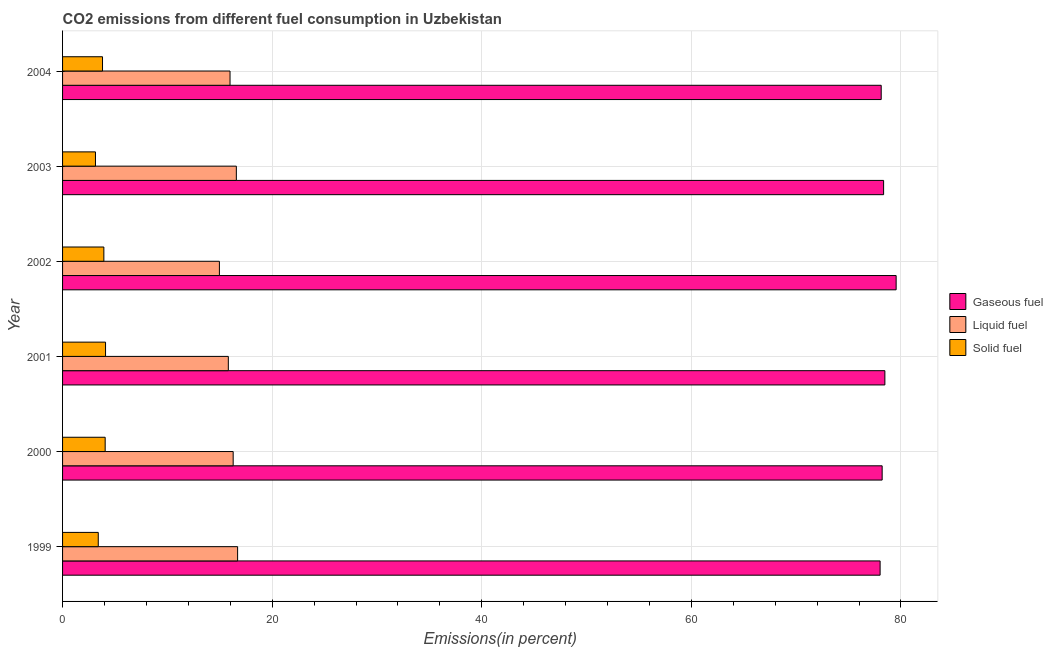How many different coloured bars are there?
Provide a short and direct response. 3. How many groups of bars are there?
Provide a succinct answer. 6. Are the number of bars per tick equal to the number of legend labels?
Keep it short and to the point. Yes. Are the number of bars on each tick of the Y-axis equal?
Offer a terse response. Yes. What is the label of the 2nd group of bars from the top?
Make the answer very short. 2003. What is the percentage of liquid fuel emission in 2004?
Your answer should be very brief. 15.98. Across all years, what is the maximum percentage of liquid fuel emission?
Keep it short and to the point. 16.7. Across all years, what is the minimum percentage of gaseous fuel emission?
Keep it short and to the point. 78.01. In which year was the percentage of gaseous fuel emission maximum?
Give a very brief answer. 2002. What is the total percentage of solid fuel emission in the graph?
Your answer should be very brief. 22.46. What is the difference between the percentage of gaseous fuel emission in 1999 and that in 2000?
Give a very brief answer. -0.2. What is the difference between the percentage of gaseous fuel emission in 2001 and the percentage of solid fuel emission in 1999?
Offer a terse response. 75.06. What is the average percentage of gaseous fuel emission per year?
Your response must be concise. 78.44. In the year 2001, what is the difference between the percentage of gaseous fuel emission and percentage of liquid fuel emission?
Provide a short and direct response. 62.65. Is the percentage of solid fuel emission in 1999 less than that in 2001?
Offer a very short reply. Yes. What is the difference between the highest and the second highest percentage of gaseous fuel emission?
Keep it short and to the point. 1.07. What is the difference between the highest and the lowest percentage of liquid fuel emission?
Keep it short and to the point. 1.74. In how many years, is the percentage of gaseous fuel emission greater than the average percentage of gaseous fuel emission taken over all years?
Give a very brief answer. 2. What does the 1st bar from the top in 1999 represents?
Your answer should be very brief. Solid fuel. What does the 1st bar from the bottom in 2002 represents?
Offer a very short reply. Gaseous fuel. How many bars are there?
Provide a short and direct response. 18. Are all the bars in the graph horizontal?
Provide a succinct answer. Yes. What is the difference between two consecutive major ticks on the X-axis?
Provide a short and direct response. 20. Does the graph contain grids?
Provide a succinct answer. Yes. Where does the legend appear in the graph?
Keep it short and to the point. Center right. How are the legend labels stacked?
Provide a succinct answer. Vertical. What is the title of the graph?
Your answer should be compact. CO2 emissions from different fuel consumption in Uzbekistan. What is the label or title of the X-axis?
Your answer should be very brief. Emissions(in percent). What is the label or title of the Y-axis?
Provide a succinct answer. Year. What is the Emissions(in percent) of Gaseous fuel in 1999?
Your answer should be very brief. 78.01. What is the Emissions(in percent) in Liquid fuel in 1999?
Ensure brevity in your answer.  16.7. What is the Emissions(in percent) in Solid fuel in 1999?
Your answer should be compact. 3.41. What is the Emissions(in percent) of Gaseous fuel in 2000?
Give a very brief answer. 78.2. What is the Emissions(in percent) in Liquid fuel in 2000?
Keep it short and to the point. 16.28. What is the Emissions(in percent) in Solid fuel in 2000?
Provide a short and direct response. 4.07. What is the Emissions(in percent) of Gaseous fuel in 2001?
Provide a short and direct response. 78.46. What is the Emissions(in percent) of Liquid fuel in 2001?
Make the answer very short. 15.82. What is the Emissions(in percent) of Solid fuel in 2001?
Make the answer very short. 4.1. What is the Emissions(in percent) in Gaseous fuel in 2002?
Keep it short and to the point. 79.54. What is the Emissions(in percent) of Liquid fuel in 2002?
Offer a very short reply. 14.97. What is the Emissions(in percent) in Solid fuel in 2002?
Your response must be concise. 3.94. What is the Emissions(in percent) of Gaseous fuel in 2003?
Provide a short and direct response. 78.34. What is the Emissions(in percent) in Liquid fuel in 2003?
Offer a very short reply. 16.58. What is the Emissions(in percent) of Solid fuel in 2003?
Give a very brief answer. 3.14. What is the Emissions(in percent) of Gaseous fuel in 2004?
Your response must be concise. 78.11. What is the Emissions(in percent) of Liquid fuel in 2004?
Give a very brief answer. 15.98. What is the Emissions(in percent) of Solid fuel in 2004?
Provide a succinct answer. 3.81. Across all years, what is the maximum Emissions(in percent) in Gaseous fuel?
Your answer should be compact. 79.54. Across all years, what is the maximum Emissions(in percent) of Liquid fuel?
Your answer should be very brief. 16.7. Across all years, what is the maximum Emissions(in percent) of Solid fuel?
Your answer should be compact. 4.1. Across all years, what is the minimum Emissions(in percent) of Gaseous fuel?
Your response must be concise. 78.01. Across all years, what is the minimum Emissions(in percent) of Liquid fuel?
Keep it short and to the point. 14.97. Across all years, what is the minimum Emissions(in percent) in Solid fuel?
Your response must be concise. 3.14. What is the total Emissions(in percent) in Gaseous fuel in the graph?
Offer a terse response. 470.66. What is the total Emissions(in percent) of Liquid fuel in the graph?
Your answer should be compact. 96.32. What is the total Emissions(in percent) of Solid fuel in the graph?
Your response must be concise. 22.46. What is the difference between the Emissions(in percent) of Gaseous fuel in 1999 and that in 2000?
Make the answer very short. -0.19. What is the difference between the Emissions(in percent) of Liquid fuel in 1999 and that in 2000?
Your answer should be very brief. 0.42. What is the difference between the Emissions(in percent) of Solid fuel in 1999 and that in 2000?
Make the answer very short. -0.66. What is the difference between the Emissions(in percent) of Gaseous fuel in 1999 and that in 2001?
Give a very brief answer. -0.45. What is the difference between the Emissions(in percent) of Liquid fuel in 1999 and that in 2001?
Ensure brevity in your answer.  0.88. What is the difference between the Emissions(in percent) in Solid fuel in 1999 and that in 2001?
Keep it short and to the point. -0.7. What is the difference between the Emissions(in percent) of Gaseous fuel in 1999 and that in 2002?
Offer a terse response. -1.53. What is the difference between the Emissions(in percent) of Liquid fuel in 1999 and that in 2002?
Provide a succinct answer. 1.74. What is the difference between the Emissions(in percent) of Solid fuel in 1999 and that in 2002?
Offer a terse response. -0.53. What is the difference between the Emissions(in percent) in Gaseous fuel in 1999 and that in 2003?
Make the answer very short. -0.33. What is the difference between the Emissions(in percent) of Liquid fuel in 1999 and that in 2003?
Offer a terse response. 0.12. What is the difference between the Emissions(in percent) of Solid fuel in 1999 and that in 2003?
Ensure brevity in your answer.  0.27. What is the difference between the Emissions(in percent) in Gaseous fuel in 1999 and that in 2004?
Keep it short and to the point. -0.1. What is the difference between the Emissions(in percent) in Liquid fuel in 1999 and that in 2004?
Give a very brief answer. 0.72. What is the difference between the Emissions(in percent) of Solid fuel in 1999 and that in 2004?
Your response must be concise. -0.41. What is the difference between the Emissions(in percent) in Gaseous fuel in 2000 and that in 2001?
Offer a very short reply. -0.26. What is the difference between the Emissions(in percent) in Liquid fuel in 2000 and that in 2001?
Provide a succinct answer. 0.46. What is the difference between the Emissions(in percent) in Solid fuel in 2000 and that in 2001?
Keep it short and to the point. -0.04. What is the difference between the Emissions(in percent) in Gaseous fuel in 2000 and that in 2002?
Your response must be concise. -1.33. What is the difference between the Emissions(in percent) of Liquid fuel in 2000 and that in 2002?
Provide a succinct answer. 1.31. What is the difference between the Emissions(in percent) of Solid fuel in 2000 and that in 2002?
Your answer should be compact. 0.13. What is the difference between the Emissions(in percent) in Gaseous fuel in 2000 and that in 2003?
Your response must be concise. -0.14. What is the difference between the Emissions(in percent) in Liquid fuel in 2000 and that in 2003?
Offer a very short reply. -0.3. What is the difference between the Emissions(in percent) of Solid fuel in 2000 and that in 2003?
Give a very brief answer. 0.93. What is the difference between the Emissions(in percent) in Gaseous fuel in 2000 and that in 2004?
Make the answer very short. 0.09. What is the difference between the Emissions(in percent) in Liquid fuel in 2000 and that in 2004?
Make the answer very short. 0.3. What is the difference between the Emissions(in percent) of Solid fuel in 2000 and that in 2004?
Your answer should be compact. 0.25. What is the difference between the Emissions(in percent) of Gaseous fuel in 2001 and that in 2002?
Your answer should be very brief. -1.07. What is the difference between the Emissions(in percent) of Liquid fuel in 2001 and that in 2002?
Keep it short and to the point. 0.85. What is the difference between the Emissions(in percent) in Solid fuel in 2001 and that in 2002?
Offer a very short reply. 0.16. What is the difference between the Emissions(in percent) of Gaseous fuel in 2001 and that in 2003?
Your answer should be compact. 0.12. What is the difference between the Emissions(in percent) of Liquid fuel in 2001 and that in 2003?
Offer a terse response. -0.76. What is the difference between the Emissions(in percent) of Solid fuel in 2001 and that in 2003?
Provide a short and direct response. 0.96. What is the difference between the Emissions(in percent) of Gaseous fuel in 2001 and that in 2004?
Keep it short and to the point. 0.35. What is the difference between the Emissions(in percent) of Liquid fuel in 2001 and that in 2004?
Your response must be concise. -0.16. What is the difference between the Emissions(in percent) of Solid fuel in 2001 and that in 2004?
Your response must be concise. 0.29. What is the difference between the Emissions(in percent) in Gaseous fuel in 2002 and that in 2003?
Offer a very short reply. 1.2. What is the difference between the Emissions(in percent) in Liquid fuel in 2002 and that in 2003?
Offer a very short reply. -1.62. What is the difference between the Emissions(in percent) in Solid fuel in 2002 and that in 2003?
Provide a short and direct response. 0.8. What is the difference between the Emissions(in percent) in Gaseous fuel in 2002 and that in 2004?
Provide a succinct answer. 1.43. What is the difference between the Emissions(in percent) of Liquid fuel in 2002 and that in 2004?
Provide a short and direct response. -1.01. What is the difference between the Emissions(in percent) of Solid fuel in 2002 and that in 2004?
Keep it short and to the point. 0.13. What is the difference between the Emissions(in percent) in Gaseous fuel in 2003 and that in 2004?
Keep it short and to the point. 0.23. What is the difference between the Emissions(in percent) in Liquid fuel in 2003 and that in 2004?
Provide a short and direct response. 0.6. What is the difference between the Emissions(in percent) in Solid fuel in 2003 and that in 2004?
Offer a very short reply. -0.67. What is the difference between the Emissions(in percent) in Gaseous fuel in 1999 and the Emissions(in percent) in Liquid fuel in 2000?
Your answer should be very brief. 61.73. What is the difference between the Emissions(in percent) of Gaseous fuel in 1999 and the Emissions(in percent) of Solid fuel in 2000?
Give a very brief answer. 73.94. What is the difference between the Emissions(in percent) in Liquid fuel in 1999 and the Emissions(in percent) in Solid fuel in 2000?
Provide a short and direct response. 12.64. What is the difference between the Emissions(in percent) of Gaseous fuel in 1999 and the Emissions(in percent) of Liquid fuel in 2001?
Make the answer very short. 62.19. What is the difference between the Emissions(in percent) of Gaseous fuel in 1999 and the Emissions(in percent) of Solid fuel in 2001?
Your answer should be very brief. 73.91. What is the difference between the Emissions(in percent) in Liquid fuel in 1999 and the Emissions(in percent) in Solid fuel in 2001?
Make the answer very short. 12.6. What is the difference between the Emissions(in percent) in Gaseous fuel in 1999 and the Emissions(in percent) in Liquid fuel in 2002?
Keep it short and to the point. 63.04. What is the difference between the Emissions(in percent) in Gaseous fuel in 1999 and the Emissions(in percent) in Solid fuel in 2002?
Your answer should be compact. 74.07. What is the difference between the Emissions(in percent) in Liquid fuel in 1999 and the Emissions(in percent) in Solid fuel in 2002?
Offer a very short reply. 12.76. What is the difference between the Emissions(in percent) of Gaseous fuel in 1999 and the Emissions(in percent) of Liquid fuel in 2003?
Make the answer very short. 61.43. What is the difference between the Emissions(in percent) of Gaseous fuel in 1999 and the Emissions(in percent) of Solid fuel in 2003?
Keep it short and to the point. 74.87. What is the difference between the Emissions(in percent) of Liquid fuel in 1999 and the Emissions(in percent) of Solid fuel in 2003?
Give a very brief answer. 13.56. What is the difference between the Emissions(in percent) in Gaseous fuel in 1999 and the Emissions(in percent) in Liquid fuel in 2004?
Provide a short and direct response. 62.03. What is the difference between the Emissions(in percent) in Gaseous fuel in 1999 and the Emissions(in percent) in Solid fuel in 2004?
Give a very brief answer. 74.2. What is the difference between the Emissions(in percent) of Liquid fuel in 1999 and the Emissions(in percent) of Solid fuel in 2004?
Give a very brief answer. 12.89. What is the difference between the Emissions(in percent) in Gaseous fuel in 2000 and the Emissions(in percent) in Liquid fuel in 2001?
Offer a terse response. 62.39. What is the difference between the Emissions(in percent) in Gaseous fuel in 2000 and the Emissions(in percent) in Solid fuel in 2001?
Keep it short and to the point. 74.1. What is the difference between the Emissions(in percent) of Liquid fuel in 2000 and the Emissions(in percent) of Solid fuel in 2001?
Your answer should be compact. 12.18. What is the difference between the Emissions(in percent) of Gaseous fuel in 2000 and the Emissions(in percent) of Liquid fuel in 2002?
Keep it short and to the point. 63.24. What is the difference between the Emissions(in percent) of Gaseous fuel in 2000 and the Emissions(in percent) of Solid fuel in 2002?
Keep it short and to the point. 74.26. What is the difference between the Emissions(in percent) in Liquid fuel in 2000 and the Emissions(in percent) in Solid fuel in 2002?
Your response must be concise. 12.34. What is the difference between the Emissions(in percent) of Gaseous fuel in 2000 and the Emissions(in percent) of Liquid fuel in 2003?
Offer a terse response. 61.62. What is the difference between the Emissions(in percent) in Gaseous fuel in 2000 and the Emissions(in percent) in Solid fuel in 2003?
Give a very brief answer. 75.06. What is the difference between the Emissions(in percent) in Liquid fuel in 2000 and the Emissions(in percent) in Solid fuel in 2003?
Your answer should be very brief. 13.14. What is the difference between the Emissions(in percent) in Gaseous fuel in 2000 and the Emissions(in percent) in Liquid fuel in 2004?
Offer a very short reply. 62.22. What is the difference between the Emissions(in percent) of Gaseous fuel in 2000 and the Emissions(in percent) of Solid fuel in 2004?
Make the answer very short. 74.39. What is the difference between the Emissions(in percent) in Liquid fuel in 2000 and the Emissions(in percent) in Solid fuel in 2004?
Provide a succinct answer. 12.47. What is the difference between the Emissions(in percent) in Gaseous fuel in 2001 and the Emissions(in percent) in Liquid fuel in 2002?
Give a very brief answer. 63.5. What is the difference between the Emissions(in percent) of Gaseous fuel in 2001 and the Emissions(in percent) of Solid fuel in 2002?
Your response must be concise. 74.52. What is the difference between the Emissions(in percent) in Liquid fuel in 2001 and the Emissions(in percent) in Solid fuel in 2002?
Your answer should be very brief. 11.88. What is the difference between the Emissions(in percent) in Gaseous fuel in 2001 and the Emissions(in percent) in Liquid fuel in 2003?
Provide a succinct answer. 61.88. What is the difference between the Emissions(in percent) in Gaseous fuel in 2001 and the Emissions(in percent) in Solid fuel in 2003?
Keep it short and to the point. 75.32. What is the difference between the Emissions(in percent) of Liquid fuel in 2001 and the Emissions(in percent) of Solid fuel in 2003?
Your response must be concise. 12.68. What is the difference between the Emissions(in percent) of Gaseous fuel in 2001 and the Emissions(in percent) of Liquid fuel in 2004?
Provide a succinct answer. 62.48. What is the difference between the Emissions(in percent) in Gaseous fuel in 2001 and the Emissions(in percent) in Solid fuel in 2004?
Offer a very short reply. 74.65. What is the difference between the Emissions(in percent) of Liquid fuel in 2001 and the Emissions(in percent) of Solid fuel in 2004?
Keep it short and to the point. 12. What is the difference between the Emissions(in percent) of Gaseous fuel in 2002 and the Emissions(in percent) of Liquid fuel in 2003?
Provide a succinct answer. 62.96. What is the difference between the Emissions(in percent) in Gaseous fuel in 2002 and the Emissions(in percent) in Solid fuel in 2003?
Offer a terse response. 76.4. What is the difference between the Emissions(in percent) in Liquid fuel in 2002 and the Emissions(in percent) in Solid fuel in 2003?
Make the answer very short. 11.83. What is the difference between the Emissions(in percent) of Gaseous fuel in 2002 and the Emissions(in percent) of Liquid fuel in 2004?
Ensure brevity in your answer.  63.56. What is the difference between the Emissions(in percent) of Gaseous fuel in 2002 and the Emissions(in percent) of Solid fuel in 2004?
Offer a very short reply. 75.72. What is the difference between the Emissions(in percent) in Liquid fuel in 2002 and the Emissions(in percent) in Solid fuel in 2004?
Offer a terse response. 11.15. What is the difference between the Emissions(in percent) in Gaseous fuel in 2003 and the Emissions(in percent) in Liquid fuel in 2004?
Your response must be concise. 62.36. What is the difference between the Emissions(in percent) in Gaseous fuel in 2003 and the Emissions(in percent) in Solid fuel in 2004?
Provide a short and direct response. 74.53. What is the difference between the Emissions(in percent) in Liquid fuel in 2003 and the Emissions(in percent) in Solid fuel in 2004?
Your response must be concise. 12.77. What is the average Emissions(in percent) of Gaseous fuel per year?
Your answer should be very brief. 78.44. What is the average Emissions(in percent) of Liquid fuel per year?
Provide a short and direct response. 16.05. What is the average Emissions(in percent) in Solid fuel per year?
Your response must be concise. 3.74. In the year 1999, what is the difference between the Emissions(in percent) of Gaseous fuel and Emissions(in percent) of Liquid fuel?
Your answer should be compact. 61.31. In the year 1999, what is the difference between the Emissions(in percent) of Gaseous fuel and Emissions(in percent) of Solid fuel?
Provide a succinct answer. 74.6. In the year 1999, what is the difference between the Emissions(in percent) of Liquid fuel and Emissions(in percent) of Solid fuel?
Keep it short and to the point. 13.3. In the year 2000, what is the difference between the Emissions(in percent) in Gaseous fuel and Emissions(in percent) in Liquid fuel?
Offer a terse response. 61.92. In the year 2000, what is the difference between the Emissions(in percent) of Gaseous fuel and Emissions(in percent) of Solid fuel?
Your response must be concise. 74.14. In the year 2000, what is the difference between the Emissions(in percent) of Liquid fuel and Emissions(in percent) of Solid fuel?
Keep it short and to the point. 12.21. In the year 2001, what is the difference between the Emissions(in percent) in Gaseous fuel and Emissions(in percent) in Liquid fuel?
Your answer should be compact. 62.65. In the year 2001, what is the difference between the Emissions(in percent) in Gaseous fuel and Emissions(in percent) in Solid fuel?
Offer a terse response. 74.36. In the year 2001, what is the difference between the Emissions(in percent) of Liquid fuel and Emissions(in percent) of Solid fuel?
Provide a succinct answer. 11.72. In the year 2002, what is the difference between the Emissions(in percent) in Gaseous fuel and Emissions(in percent) in Liquid fuel?
Provide a short and direct response. 64.57. In the year 2002, what is the difference between the Emissions(in percent) in Gaseous fuel and Emissions(in percent) in Solid fuel?
Make the answer very short. 75.6. In the year 2002, what is the difference between the Emissions(in percent) of Liquid fuel and Emissions(in percent) of Solid fuel?
Your response must be concise. 11.03. In the year 2003, what is the difference between the Emissions(in percent) of Gaseous fuel and Emissions(in percent) of Liquid fuel?
Your answer should be compact. 61.76. In the year 2003, what is the difference between the Emissions(in percent) in Gaseous fuel and Emissions(in percent) in Solid fuel?
Give a very brief answer. 75.2. In the year 2003, what is the difference between the Emissions(in percent) of Liquid fuel and Emissions(in percent) of Solid fuel?
Offer a terse response. 13.44. In the year 2004, what is the difference between the Emissions(in percent) of Gaseous fuel and Emissions(in percent) of Liquid fuel?
Your answer should be compact. 62.13. In the year 2004, what is the difference between the Emissions(in percent) in Gaseous fuel and Emissions(in percent) in Solid fuel?
Provide a short and direct response. 74.3. In the year 2004, what is the difference between the Emissions(in percent) in Liquid fuel and Emissions(in percent) in Solid fuel?
Offer a terse response. 12.17. What is the ratio of the Emissions(in percent) of Liquid fuel in 1999 to that in 2000?
Your answer should be very brief. 1.03. What is the ratio of the Emissions(in percent) of Solid fuel in 1999 to that in 2000?
Keep it short and to the point. 0.84. What is the ratio of the Emissions(in percent) in Gaseous fuel in 1999 to that in 2001?
Your answer should be compact. 0.99. What is the ratio of the Emissions(in percent) in Liquid fuel in 1999 to that in 2001?
Your answer should be very brief. 1.06. What is the ratio of the Emissions(in percent) of Solid fuel in 1999 to that in 2001?
Your answer should be very brief. 0.83. What is the ratio of the Emissions(in percent) in Gaseous fuel in 1999 to that in 2002?
Your answer should be very brief. 0.98. What is the ratio of the Emissions(in percent) of Liquid fuel in 1999 to that in 2002?
Provide a succinct answer. 1.12. What is the ratio of the Emissions(in percent) in Solid fuel in 1999 to that in 2002?
Ensure brevity in your answer.  0.86. What is the ratio of the Emissions(in percent) of Solid fuel in 1999 to that in 2003?
Provide a succinct answer. 1.08. What is the ratio of the Emissions(in percent) of Gaseous fuel in 1999 to that in 2004?
Offer a terse response. 1. What is the ratio of the Emissions(in percent) in Liquid fuel in 1999 to that in 2004?
Provide a short and direct response. 1.05. What is the ratio of the Emissions(in percent) of Solid fuel in 1999 to that in 2004?
Your answer should be compact. 0.89. What is the ratio of the Emissions(in percent) of Liquid fuel in 2000 to that in 2001?
Give a very brief answer. 1.03. What is the ratio of the Emissions(in percent) of Solid fuel in 2000 to that in 2001?
Make the answer very short. 0.99. What is the ratio of the Emissions(in percent) of Gaseous fuel in 2000 to that in 2002?
Give a very brief answer. 0.98. What is the ratio of the Emissions(in percent) of Liquid fuel in 2000 to that in 2002?
Provide a succinct answer. 1.09. What is the ratio of the Emissions(in percent) of Solid fuel in 2000 to that in 2002?
Provide a short and direct response. 1.03. What is the ratio of the Emissions(in percent) in Gaseous fuel in 2000 to that in 2003?
Provide a succinct answer. 1. What is the ratio of the Emissions(in percent) of Liquid fuel in 2000 to that in 2003?
Your answer should be compact. 0.98. What is the ratio of the Emissions(in percent) in Solid fuel in 2000 to that in 2003?
Your answer should be very brief. 1.29. What is the ratio of the Emissions(in percent) in Liquid fuel in 2000 to that in 2004?
Offer a very short reply. 1.02. What is the ratio of the Emissions(in percent) of Solid fuel in 2000 to that in 2004?
Offer a terse response. 1.07. What is the ratio of the Emissions(in percent) in Gaseous fuel in 2001 to that in 2002?
Offer a terse response. 0.99. What is the ratio of the Emissions(in percent) of Liquid fuel in 2001 to that in 2002?
Offer a very short reply. 1.06. What is the ratio of the Emissions(in percent) of Solid fuel in 2001 to that in 2002?
Your response must be concise. 1.04. What is the ratio of the Emissions(in percent) in Liquid fuel in 2001 to that in 2003?
Your response must be concise. 0.95. What is the ratio of the Emissions(in percent) of Solid fuel in 2001 to that in 2003?
Provide a short and direct response. 1.31. What is the ratio of the Emissions(in percent) in Gaseous fuel in 2001 to that in 2004?
Give a very brief answer. 1. What is the ratio of the Emissions(in percent) in Solid fuel in 2001 to that in 2004?
Offer a very short reply. 1.08. What is the ratio of the Emissions(in percent) of Gaseous fuel in 2002 to that in 2003?
Provide a short and direct response. 1.02. What is the ratio of the Emissions(in percent) in Liquid fuel in 2002 to that in 2003?
Ensure brevity in your answer.  0.9. What is the ratio of the Emissions(in percent) in Solid fuel in 2002 to that in 2003?
Offer a terse response. 1.25. What is the ratio of the Emissions(in percent) in Gaseous fuel in 2002 to that in 2004?
Give a very brief answer. 1.02. What is the ratio of the Emissions(in percent) in Liquid fuel in 2002 to that in 2004?
Offer a very short reply. 0.94. What is the ratio of the Emissions(in percent) of Solid fuel in 2002 to that in 2004?
Ensure brevity in your answer.  1.03. What is the ratio of the Emissions(in percent) of Gaseous fuel in 2003 to that in 2004?
Make the answer very short. 1. What is the ratio of the Emissions(in percent) in Liquid fuel in 2003 to that in 2004?
Offer a very short reply. 1.04. What is the ratio of the Emissions(in percent) in Solid fuel in 2003 to that in 2004?
Your answer should be compact. 0.82. What is the difference between the highest and the second highest Emissions(in percent) in Gaseous fuel?
Your answer should be compact. 1.07. What is the difference between the highest and the second highest Emissions(in percent) in Liquid fuel?
Your answer should be compact. 0.12. What is the difference between the highest and the second highest Emissions(in percent) in Solid fuel?
Make the answer very short. 0.04. What is the difference between the highest and the lowest Emissions(in percent) of Gaseous fuel?
Provide a short and direct response. 1.53. What is the difference between the highest and the lowest Emissions(in percent) in Liquid fuel?
Your answer should be compact. 1.74. What is the difference between the highest and the lowest Emissions(in percent) of Solid fuel?
Keep it short and to the point. 0.96. 